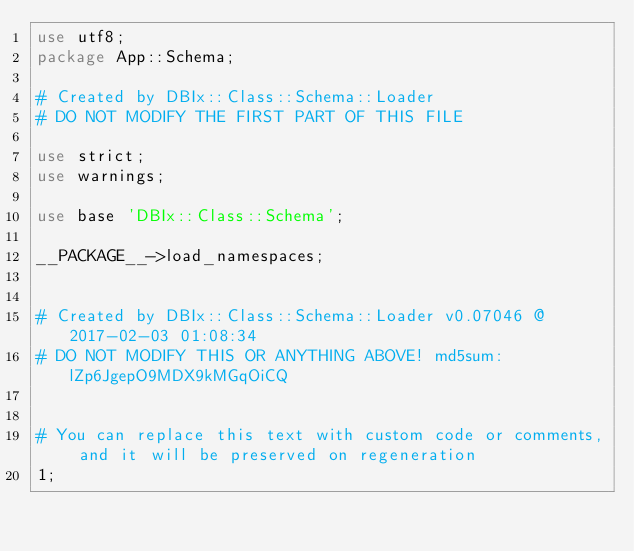Convert code to text. <code><loc_0><loc_0><loc_500><loc_500><_Perl_>use utf8;
package App::Schema;

# Created by DBIx::Class::Schema::Loader
# DO NOT MODIFY THE FIRST PART OF THIS FILE

use strict;
use warnings;

use base 'DBIx::Class::Schema';

__PACKAGE__->load_namespaces;


# Created by DBIx::Class::Schema::Loader v0.07046 @ 2017-02-03 01:08:34
# DO NOT MODIFY THIS OR ANYTHING ABOVE! md5sum:lZp6JgepO9MDX9kMGqOiCQ


# You can replace this text with custom code or comments, and it will be preserved on regeneration
1;
</code> 